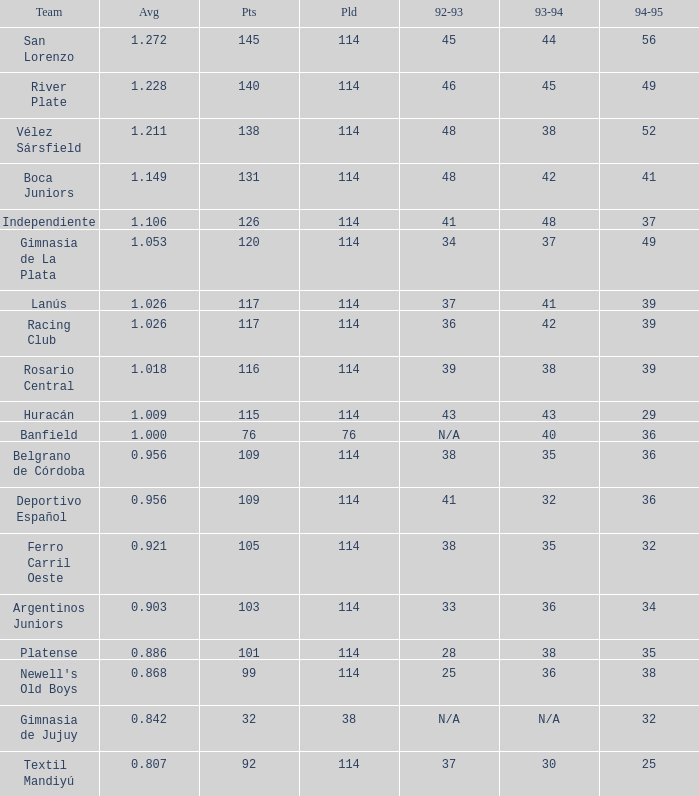Name the most played 114.0. 